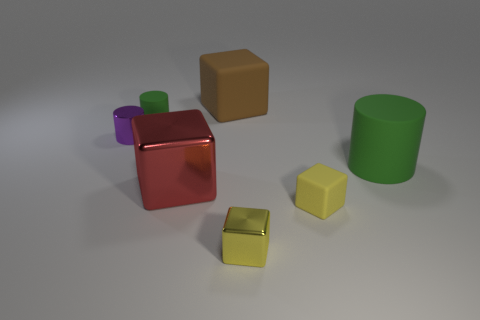What is the size of the cylinder that is to the left of the large metal block and in front of the small green thing?
Provide a succinct answer. Small. There is a object that is on the left side of the green rubber thing behind the large rubber object in front of the small purple metallic cylinder; how big is it?
Your answer should be compact. Small. How big is the purple metal cylinder?
Offer a terse response. Small. There is a cylinder in front of the small cylinder in front of the tiny rubber cylinder; are there any green things to the left of it?
Your response must be concise. Yes. What number of tiny things are brown shiny cubes or blocks?
Offer a very short reply. 2. Is there anything else of the same color as the tiny metallic cylinder?
Provide a short and direct response. No. Does the rubber cylinder that is behind the purple cylinder have the same size as the small rubber block?
Offer a very short reply. Yes. What is the color of the small rubber object left of the rubber block behind the metal thing behind the big green rubber cylinder?
Your answer should be very brief. Green. What color is the big cylinder?
Your response must be concise. Green. Does the tiny shiny cube have the same color as the tiny rubber cube?
Ensure brevity in your answer.  Yes. 